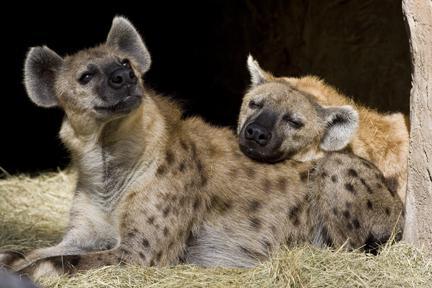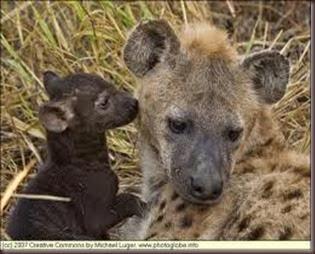The first image is the image on the left, the second image is the image on the right. Assess this claim about the two images: "A single animal stands in one of the images, while an animal lies on the ground in the other.". Correct or not? Answer yes or no. No. The first image is the image on the left, the second image is the image on the right. Given the left and right images, does the statement "The combined images contain a total of four hyenas, including at least one hyena pup posed with its parent." hold true? Answer yes or no. Yes. 